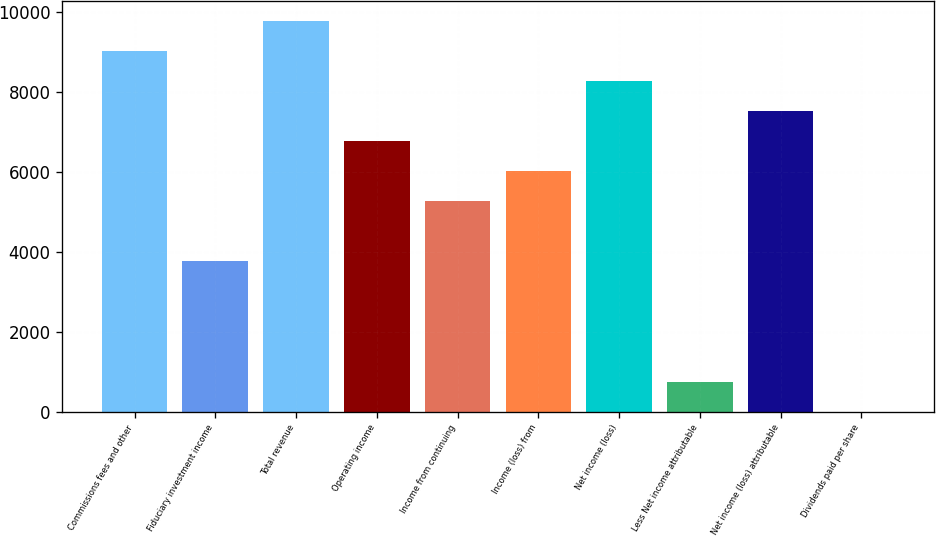Convert chart. <chart><loc_0><loc_0><loc_500><loc_500><bar_chart><fcel>Commissions fees and other<fcel>Fiduciary investment income<fcel>Total revenue<fcel>Operating income<fcel>Income from continuing<fcel>Income (loss) from<fcel>Net income (loss)<fcel>Less Net income attributable<fcel>Net income (loss) attributable<fcel>Dividends paid per share<nl><fcel>9033.48<fcel>3764.3<fcel>9786.22<fcel>6775.26<fcel>5269.78<fcel>6022.52<fcel>8280.74<fcel>753.34<fcel>7528<fcel>0.6<nl></chart> 